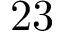<formula> <loc_0><loc_0><loc_500><loc_500>2 3</formula> 